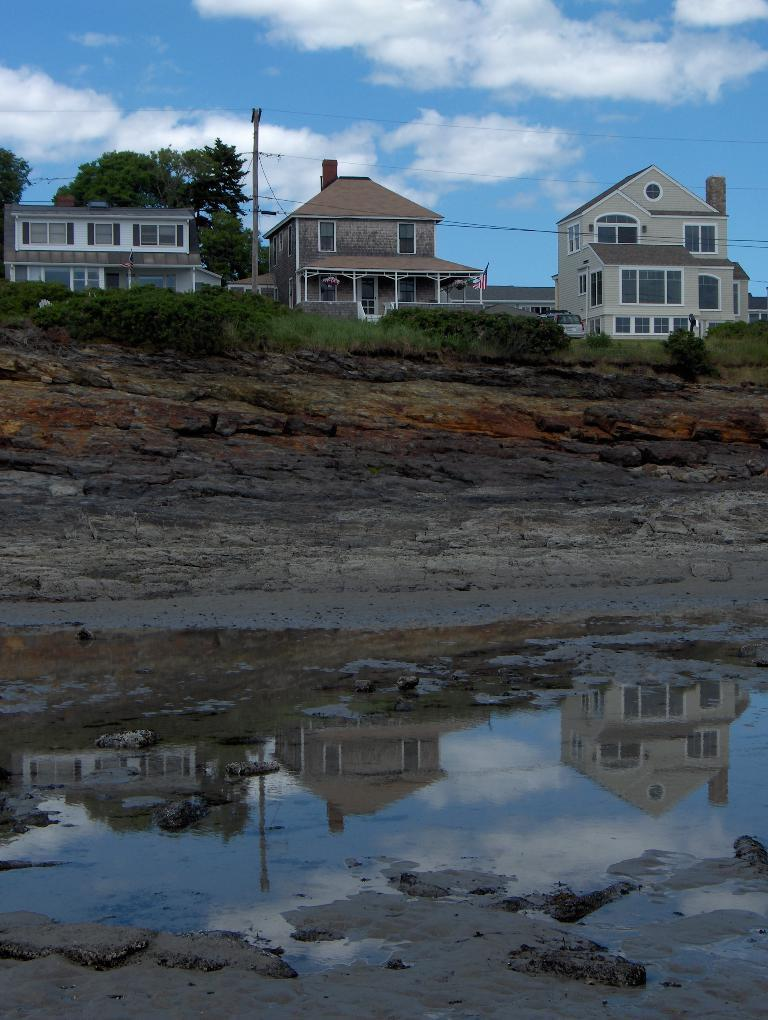What type of structures can be seen in the background of the image? There are houses in the background of the image. What other natural elements can be seen in the background? There are trees, grass, and water visible in the background of the image. What man-made objects are present in the background? There is a board and wires in the background of the image. What part of the natural environment is visible at the top of the image? The sky is visible at the top of the image. Can you tell me how many sails are visible on the donkey in the image? There is no donkey or sail present in the image. What type of light can be seen illuminating the houses in the image? There is no specific light source mentioned in the image, and the lighting conditions are not described. 